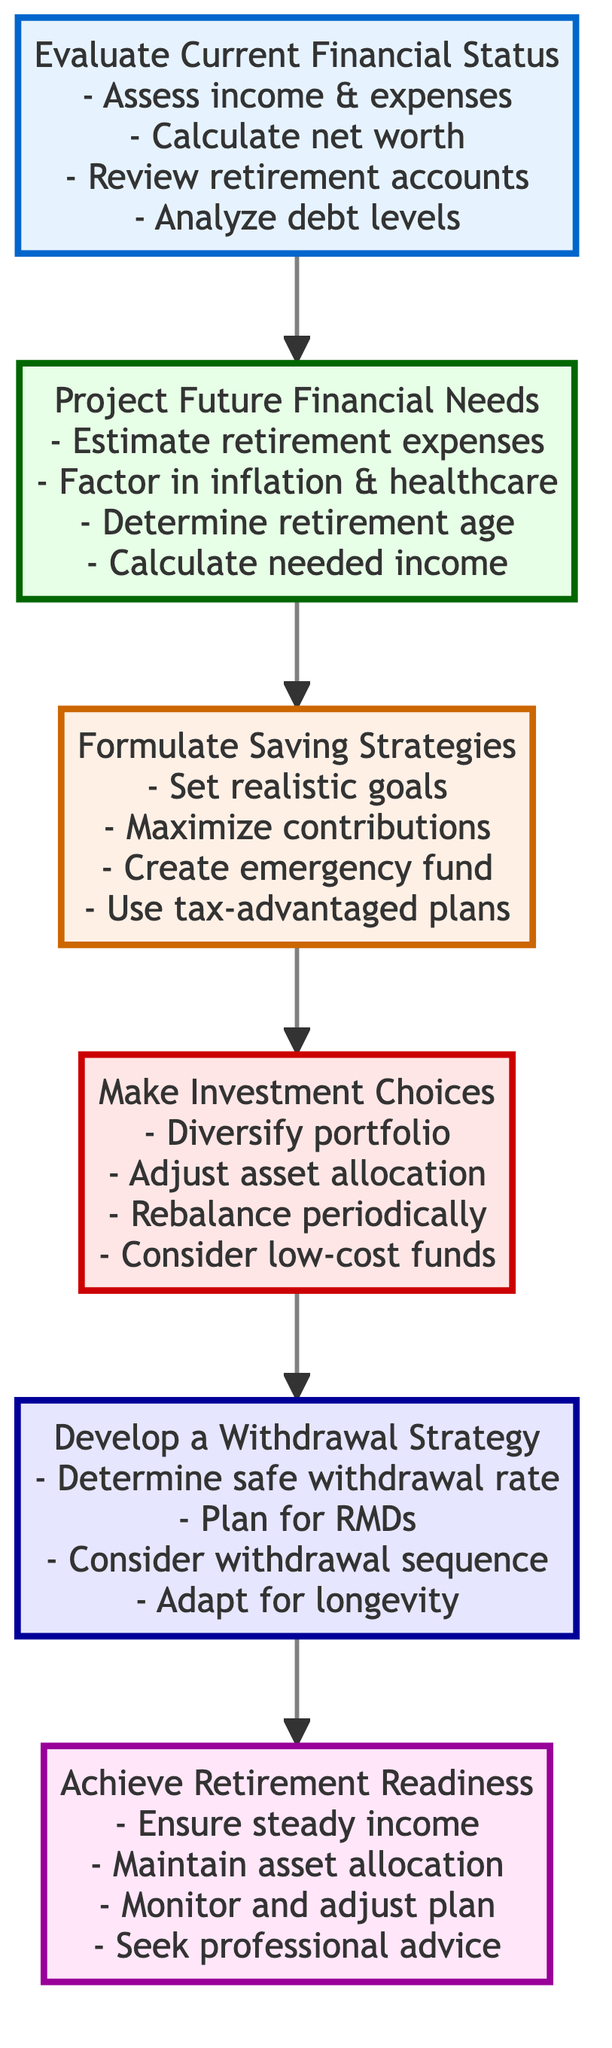What is the final step in the process? The diagram indicates that the final step at the top of the flow chart is "Achieve Retirement Readiness," which represents the concluding phase of the retirement planning process.
Answer: Achieve Retirement Readiness How many levels are there in the flow chart? The flow chart consists of six distinct levels, each representing different stages in the retirement planning process starting from evaluating current financial status to achieving retirement readiness.
Answer: Six What is the second step in the process? In the flow chart, the second step following "Evaluate Current Financial Status" is "Project Future Financial Needs," establishing a clear sequential progression in the planning process.
Answer: Project Future Financial Needs What details are involved in the "Formulate Saving Strategies"? The node for "Formulate Saving Strategies" includes several key details: set realistic savings goals, maximize contributions to retirement accounts, create an emergency fund, and implement tax-advantaged savings plans, reflecting important strategies for effective saving.
Answer: Set realistic savings goals, maximize contributions to retirement accounts, create an emergency fund, implement tax-advantaged savings plans Which node directly precedes "Make Investment Choices"? The node that comes immediately before "Make Investment Choices" in the flow chart is "Formulate Saving Strategies," indicating that saving strategies should be developed prior to making investment decisions.
Answer: Formulate Saving Strategies How can "Achieve Retirement Readiness" be maintained? The flow chart details that maintaining "Achieve Retirement Readiness" involves ensuring steady income streams, maintaining proper asset allocation, monitoring and adjusting the plan as needed, and seeking professional financial advice periodically.
Answer: Ensure steady income streams, maintain proper asset allocation, monitor and adjust plan, seek professional advice What element factors into the "Project Future Financial Needs"? One of the critical elements that must be factored into "Project Future Financial Needs" is estimating retirement living expenses, which helps determine how much income will be needed in retirement.
Answer: Estimate retirement living expenses What detail is NOT included in "Develop a Withdrawal Strategy"? The detail that is not included in "Develop a Withdrawal Strategy" is related to aspects of saving or investment, as this section focuses specifically on creating a strategic plan for withdrawing funds during retirement.
Answer: Aspects of saving or investment 